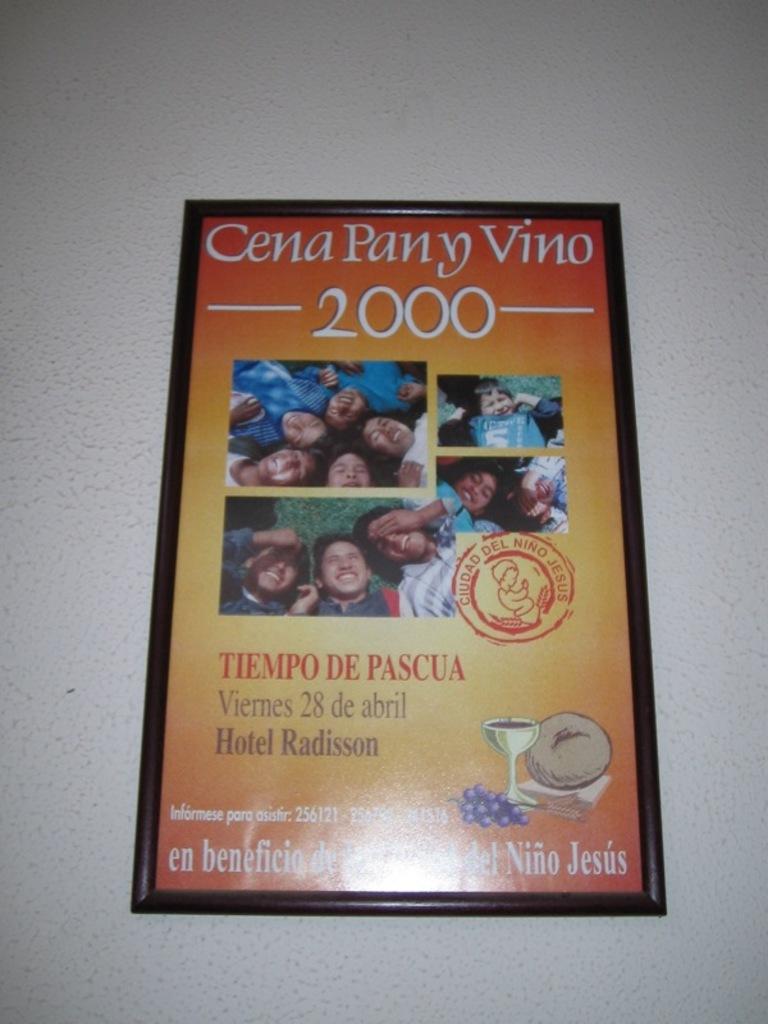Is this for a wine festival?
Offer a terse response. Yes. What year was this?
Provide a succinct answer. 2000. 